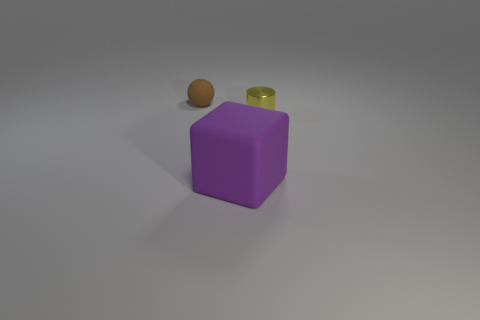Is the size of the brown ball the same as the metallic cylinder?
Provide a short and direct response. Yes. There is a small object on the right side of the brown matte thing; what color is it?
Your response must be concise. Yellow. The brown sphere that is the same material as the purple thing is what size?
Your answer should be very brief. Small. There is a cylinder; is its size the same as the rubber thing in front of the metal thing?
Give a very brief answer. No. There is a tiny thing to the right of the tiny brown object; what is its material?
Provide a short and direct response. Metal. How many tiny yellow metal objects are right of the object right of the big rubber block?
Offer a very short reply. 0. Is there another rubber object of the same shape as the yellow object?
Provide a succinct answer. No. Does the rubber thing in front of the yellow shiny cylinder have the same size as the matte object that is behind the matte cube?
Your response must be concise. No. There is a matte object on the right side of the rubber object behind the large purple rubber thing; what shape is it?
Give a very brief answer. Cube. How many brown matte balls are the same size as the yellow metal thing?
Your answer should be very brief. 1. 